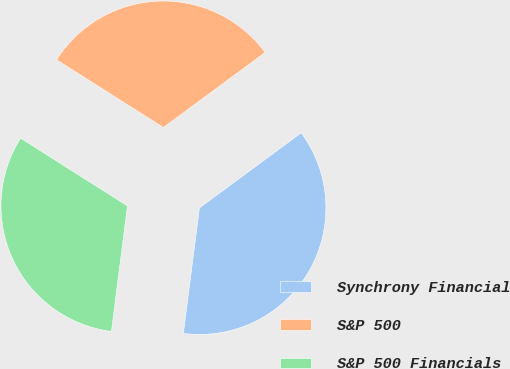Convert chart. <chart><loc_0><loc_0><loc_500><loc_500><pie_chart><fcel>Synchrony Financial<fcel>S&P 500<fcel>S&P 500 Financials<nl><fcel>37.14%<fcel>30.89%<fcel>31.97%<nl></chart> 